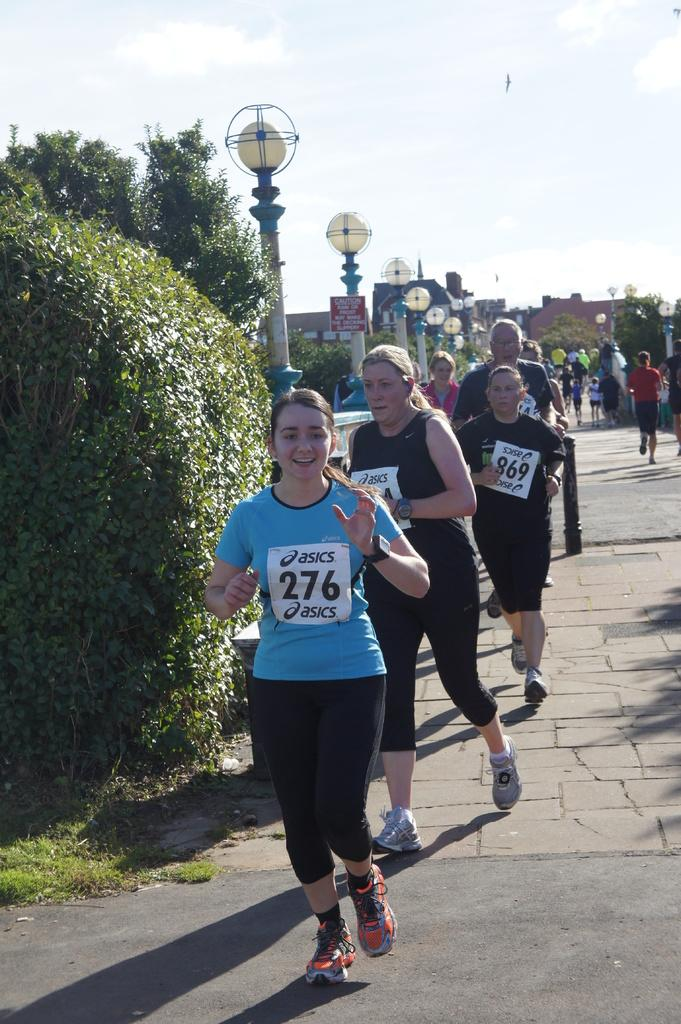What are the people in the image doing? The people in the image are running on the road. What can be seen on the left side of the image? There are lights on the left side of the image. What is visible in the background of the image? There are buildings and trees in the background of the image. What is visible at the top of the image? The sky is visible at the top of the image. Where is the harbor located in the image? There is no harbor present in the image. How many oranges are being carried by the people running in the image? There are no oranges visible in the image; the people are running without any objects. 